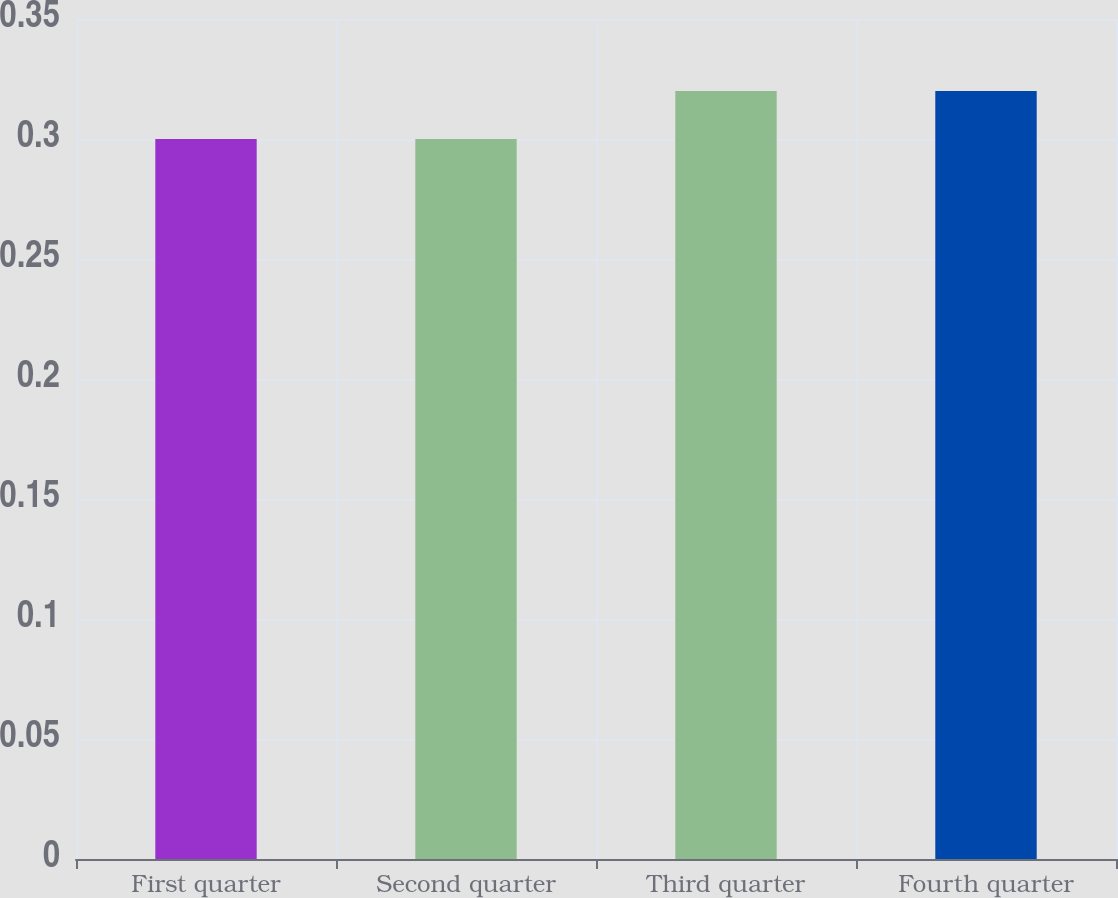<chart> <loc_0><loc_0><loc_500><loc_500><bar_chart><fcel>First quarter<fcel>Second quarter<fcel>Third quarter<fcel>Fourth quarter<nl><fcel>0.3<fcel>0.3<fcel>0.32<fcel>0.32<nl></chart> 